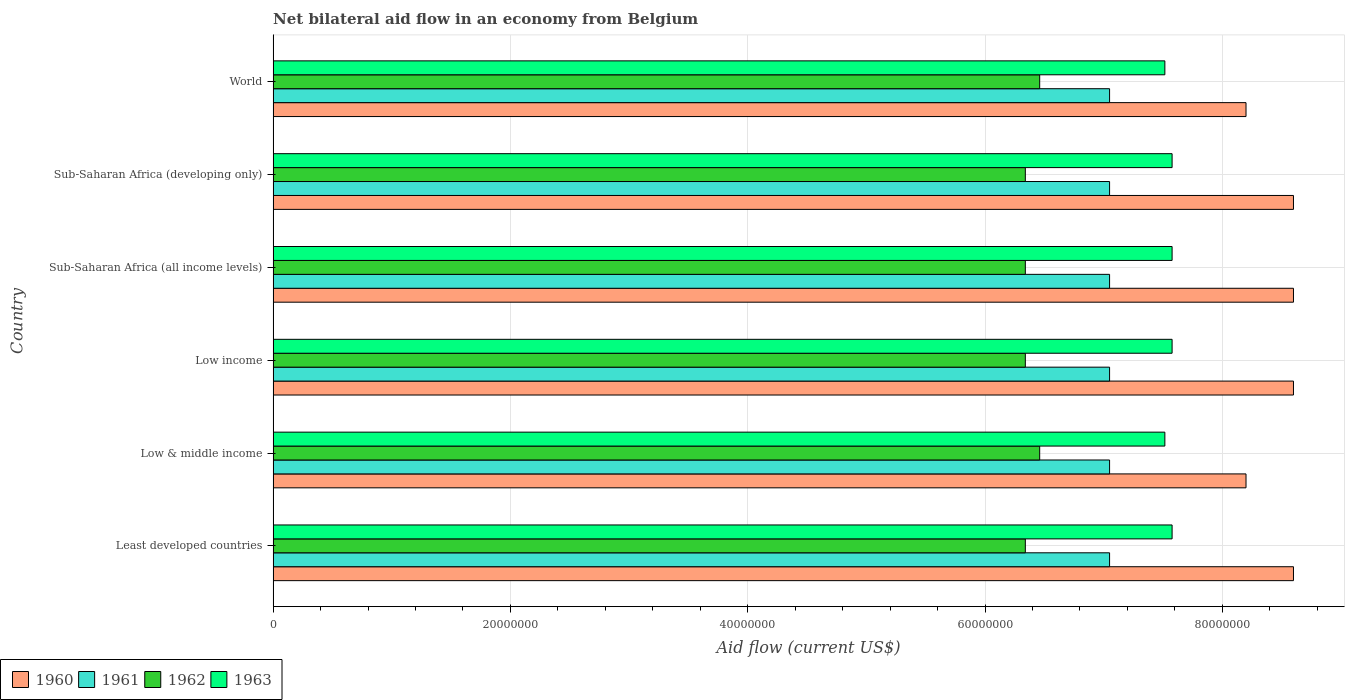Are the number of bars per tick equal to the number of legend labels?
Give a very brief answer. Yes. How many bars are there on the 6th tick from the top?
Your response must be concise. 4. What is the net bilateral aid flow in 1961 in Low & middle income?
Make the answer very short. 7.05e+07. Across all countries, what is the maximum net bilateral aid flow in 1963?
Offer a terse response. 7.58e+07. Across all countries, what is the minimum net bilateral aid flow in 1960?
Keep it short and to the point. 8.20e+07. In which country was the net bilateral aid flow in 1963 maximum?
Make the answer very short. Least developed countries. In which country was the net bilateral aid flow in 1961 minimum?
Make the answer very short. Least developed countries. What is the total net bilateral aid flow in 1963 in the graph?
Your response must be concise. 4.53e+08. What is the difference between the net bilateral aid flow in 1963 in Low income and the net bilateral aid flow in 1962 in Low & middle income?
Offer a terse response. 1.12e+07. What is the average net bilateral aid flow in 1962 per country?
Offer a very short reply. 6.38e+07. What is the difference between the net bilateral aid flow in 1961 and net bilateral aid flow in 1963 in Sub-Saharan Africa (all income levels)?
Your answer should be compact. -5.27e+06. What is the ratio of the net bilateral aid flow in 1962 in Sub-Saharan Africa (all income levels) to that in World?
Your answer should be compact. 0.98. Is the net bilateral aid flow in 1961 in Low & middle income less than that in Sub-Saharan Africa (developing only)?
Keep it short and to the point. No. What is the difference between the highest and the second highest net bilateral aid flow in 1960?
Offer a very short reply. 0. What is the difference between the highest and the lowest net bilateral aid flow in 1962?
Keep it short and to the point. 1.21e+06. In how many countries, is the net bilateral aid flow in 1960 greater than the average net bilateral aid flow in 1960 taken over all countries?
Give a very brief answer. 4. Is the sum of the net bilateral aid flow in 1961 in Low & middle income and World greater than the maximum net bilateral aid flow in 1960 across all countries?
Ensure brevity in your answer.  Yes. Is it the case that in every country, the sum of the net bilateral aid flow in 1961 and net bilateral aid flow in 1962 is greater than the sum of net bilateral aid flow in 1960 and net bilateral aid flow in 1963?
Keep it short and to the point. No. What does the 1st bar from the top in Low income represents?
Provide a short and direct response. 1963. Is it the case that in every country, the sum of the net bilateral aid flow in 1962 and net bilateral aid flow in 1961 is greater than the net bilateral aid flow in 1960?
Your answer should be very brief. Yes. How many bars are there?
Provide a short and direct response. 24. How many countries are there in the graph?
Your response must be concise. 6. Does the graph contain any zero values?
Your answer should be very brief. No. How many legend labels are there?
Offer a terse response. 4. What is the title of the graph?
Offer a very short reply. Net bilateral aid flow in an economy from Belgium. Does "1963" appear as one of the legend labels in the graph?
Provide a short and direct response. Yes. What is the Aid flow (current US$) in 1960 in Least developed countries?
Keep it short and to the point. 8.60e+07. What is the Aid flow (current US$) of 1961 in Least developed countries?
Your answer should be compact. 7.05e+07. What is the Aid flow (current US$) in 1962 in Least developed countries?
Keep it short and to the point. 6.34e+07. What is the Aid flow (current US$) of 1963 in Least developed countries?
Provide a short and direct response. 7.58e+07. What is the Aid flow (current US$) in 1960 in Low & middle income?
Keep it short and to the point. 8.20e+07. What is the Aid flow (current US$) of 1961 in Low & middle income?
Your answer should be very brief. 7.05e+07. What is the Aid flow (current US$) of 1962 in Low & middle income?
Make the answer very short. 6.46e+07. What is the Aid flow (current US$) in 1963 in Low & middle income?
Your answer should be compact. 7.52e+07. What is the Aid flow (current US$) of 1960 in Low income?
Your response must be concise. 8.60e+07. What is the Aid flow (current US$) of 1961 in Low income?
Your response must be concise. 7.05e+07. What is the Aid flow (current US$) in 1962 in Low income?
Provide a short and direct response. 6.34e+07. What is the Aid flow (current US$) in 1963 in Low income?
Offer a very short reply. 7.58e+07. What is the Aid flow (current US$) of 1960 in Sub-Saharan Africa (all income levels)?
Provide a short and direct response. 8.60e+07. What is the Aid flow (current US$) of 1961 in Sub-Saharan Africa (all income levels)?
Offer a terse response. 7.05e+07. What is the Aid flow (current US$) of 1962 in Sub-Saharan Africa (all income levels)?
Your answer should be compact. 6.34e+07. What is the Aid flow (current US$) of 1963 in Sub-Saharan Africa (all income levels)?
Your answer should be very brief. 7.58e+07. What is the Aid flow (current US$) of 1960 in Sub-Saharan Africa (developing only)?
Provide a short and direct response. 8.60e+07. What is the Aid flow (current US$) in 1961 in Sub-Saharan Africa (developing only)?
Offer a terse response. 7.05e+07. What is the Aid flow (current US$) of 1962 in Sub-Saharan Africa (developing only)?
Keep it short and to the point. 6.34e+07. What is the Aid flow (current US$) in 1963 in Sub-Saharan Africa (developing only)?
Your answer should be very brief. 7.58e+07. What is the Aid flow (current US$) in 1960 in World?
Ensure brevity in your answer.  8.20e+07. What is the Aid flow (current US$) in 1961 in World?
Your answer should be very brief. 7.05e+07. What is the Aid flow (current US$) in 1962 in World?
Offer a terse response. 6.46e+07. What is the Aid flow (current US$) of 1963 in World?
Make the answer very short. 7.52e+07. Across all countries, what is the maximum Aid flow (current US$) in 1960?
Give a very brief answer. 8.60e+07. Across all countries, what is the maximum Aid flow (current US$) in 1961?
Provide a succinct answer. 7.05e+07. Across all countries, what is the maximum Aid flow (current US$) of 1962?
Make the answer very short. 6.46e+07. Across all countries, what is the maximum Aid flow (current US$) in 1963?
Offer a terse response. 7.58e+07. Across all countries, what is the minimum Aid flow (current US$) of 1960?
Your answer should be very brief. 8.20e+07. Across all countries, what is the minimum Aid flow (current US$) in 1961?
Offer a very short reply. 7.05e+07. Across all countries, what is the minimum Aid flow (current US$) of 1962?
Your answer should be compact. 6.34e+07. Across all countries, what is the minimum Aid flow (current US$) in 1963?
Make the answer very short. 7.52e+07. What is the total Aid flow (current US$) in 1960 in the graph?
Provide a short and direct response. 5.08e+08. What is the total Aid flow (current US$) in 1961 in the graph?
Your answer should be very brief. 4.23e+08. What is the total Aid flow (current US$) in 1962 in the graph?
Ensure brevity in your answer.  3.83e+08. What is the total Aid flow (current US$) in 1963 in the graph?
Keep it short and to the point. 4.53e+08. What is the difference between the Aid flow (current US$) in 1960 in Least developed countries and that in Low & middle income?
Keep it short and to the point. 4.00e+06. What is the difference between the Aid flow (current US$) in 1962 in Least developed countries and that in Low & middle income?
Your answer should be very brief. -1.21e+06. What is the difference between the Aid flow (current US$) in 1960 in Least developed countries and that in Low income?
Your answer should be compact. 0. What is the difference between the Aid flow (current US$) in 1961 in Least developed countries and that in Low income?
Your response must be concise. 0. What is the difference between the Aid flow (current US$) in 1962 in Least developed countries and that in Low income?
Make the answer very short. 0. What is the difference between the Aid flow (current US$) of 1963 in Least developed countries and that in Low income?
Your response must be concise. 0. What is the difference between the Aid flow (current US$) of 1961 in Least developed countries and that in Sub-Saharan Africa (all income levels)?
Your answer should be compact. 0. What is the difference between the Aid flow (current US$) in 1962 in Least developed countries and that in Sub-Saharan Africa (all income levels)?
Your answer should be compact. 0. What is the difference between the Aid flow (current US$) in 1960 in Least developed countries and that in Sub-Saharan Africa (developing only)?
Give a very brief answer. 0. What is the difference between the Aid flow (current US$) of 1961 in Least developed countries and that in Sub-Saharan Africa (developing only)?
Provide a succinct answer. 0. What is the difference between the Aid flow (current US$) of 1963 in Least developed countries and that in Sub-Saharan Africa (developing only)?
Keep it short and to the point. 0. What is the difference between the Aid flow (current US$) of 1960 in Least developed countries and that in World?
Keep it short and to the point. 4.00e+06. What is the difference between the Aid flow (current US$) in 1962 in Least developed countries and that in World?
Give a very brief answer. -1.21e+06. What is the difference between the Aid flow (current US$) in 1962 in Low & middle income and that in Low income?
Offer a terse response. 1.21e+06. What is the difference between the Aid flow (current US$) of 1963 in Low & middle income and that in Low income?
Your response must be concise. -6.10e+05. What is the difference between the Aid flow (current US$) of 1960 in Low & middle income and that in Sub-Saharan Africa (all income levels)?
Your answer should be very brief. -4.00e+06. What is the difference between the Aid flow (current US$) of 1961 in Low & middle income and that in Sub-Saharan Africa (all income levels)?
Offer a terse response. 0. What is the difference between the Aid flow (current US$) in 1962 in Low & middle income and that in Sub-Saharan Africa (all income levels)?
Offer a very short reply. 1.21e+06. What is the difference between the Aid flow (current US$) of 1963 in Low & middle income and that in Sub-Saharan Africa (all income levels)?
Keep it short and to the point. -6.10e+05. What is the difference between the Aid flow (current US$) in 1960 in Low & middle income and that in Sub-Saharan Africa (developing only)?
Ensure brevity in your answer.  -4.00e+06. What is the difference between the Aid flow (current US$) in 1961 in Low & middle income and that in Sub-Saharan Africa (developing only)?
Your answer should be very brief. 0. What is the difference between the Aid flow (current US$) of 1962 in Low & middle income and that in Sub-Saharan Africa (developing only)?
Ensure brevity in your answer.  1.21e+06. What is the difference between the Aid flow (current US$) in 1963 in Low & middle income and that in Sub-Saharan Africa (developing only)?
Your answer should be compact. -6.10e+05. What is the difference between the Aid flow (current US$) in 1960 in Low & middle income and that in World?
Your answer should be very brief. 0. What is the difference between the Aid flow (current US$) of 1961 in Low & middle income and that in World?
Keep it short and to the point. 0. What is the difference between the Aid flow (current US$) in 1962 in Low & middle income and that in World?
Ensure brevity in your answer.  0. What is the difference between the Aid flow (current US$) in 1961 in Low income and that in Sub-Saharan Africa (all income levels)?
Keep it short and to the point. 0. What is the difference between the Aid flow (current US$) in 1962 in Low income and that in Sub-Saharan Africa (developing only)?
Offer a terse response. 0. What is the difference between the Aid flow (current US$) of 1960 in Low income and that in World?
Your response must be concise. 4.00e+06. What is the difference between the Aid flow (current US$) of 1962 in Low income and that in World?
Give a very brief answer. -1.21e+06. What is the difference between the Aid flow (current US$) in 1961 in Sub-Saharan Africa (all income levels) and that in Sub-Saharan Africa (developing only)?
Give a very brief answer. 0. What is the difference between the Aid flow (current US$) in 1963 in Sub-Saharan Africa (all income levels) and that in Sub-Saharan Africa (developing only)?
Give a very brief answer. 0. What is the difference between the Aid flow (current US$) of 1962 in Sub-Saharan Africa (all income levels) and that in World?
Your answer should be very brief. -1.21e+06. What is the difference between the Aid flow (current US$) of 1963 in Sub-Saharan Africa (all income levels) and that in World?
Keep it short and to the point. 6.10e+05. What is the difference between the Aid flow (current US$) of 1960 in Sub-Saharan Africa (developing only) and that in World?
Keep it short and to the point. 4.00e+06. What is the difference between the Aid flow (current US$) in 1962 in Sub-Saharan Africa (developing only) and that in World?
Give a very brief answer. -1.21e+06. What is the difference between the Aid flow (current US$) in 1963 in Sub-Saharan Africa (developing only) and that in World?
Make the answer very short. 6.10e+05. What is the difference between the Aid flow (current US$) of 1960 in Least developed countries and the Aid flow (current US$) of 1961 in Low & middle income?
Your answer should be compact. 1.55e+07. What is the difference between the Aid flow (current US$) in 1960 in Least developed countries and the Aid flow (current US$) in 1962 in Low & middle income?
Give a very brief answer. 2.14e+07. What is the difference between the Aid flow (current US$) of 1960 in Least developed countries and the Aid flow (current US$) of 1963 in Low & middle income?
Ensure brevity in your answer.  1.08e+07. What is the difference between the Aid flow (current US$) of 1961 in Least developed countries and the Aid flow (current US$) of 1962 in Low & middle income?
Ensure brevity in your answer.  5.89e+06. What is the difference between the Aid flow (current US$) of 1961 in Least developed countries and the Aid flow (current US$) of 1963 in Low & middle income?
Your answer should be very brief. -4.66e+06. What is the difference between the Aid flow (current US$) of 1962 in Least developed countries and the Aid flow (current US$) of 1963 in Low & middle income?
Provide a short and direct response. -1.18e+07. What is the difference between the Aid flow (current US$) in 1960 in Least developed countries and the Aid flow (current US$) in 1961 in Low income?
Offer a very short reply. 1.55e+07. What is the difference between the Aid flow (current US$) of 1960 in Least developed countries and the Aid flow (current US$) of 1962 in Low income?
Keep it short and to the point. 2.26e+07. What is the difference between the Aid flow (current US$) of 1960 in Least developed countries and the Aid flow (current US$) of 1963 in Low income?
Your answer should be compact. 1.02e+07. What is the difference between the Aid flow (current US$) of 1961 in Least developed countries and the Aid flow (current US$) of 1962 in Low income?
Provide a succinct answer. 7.10e+06. What is the difference between the Aid flow (current US$) in 1961 in Least developed countries and the Aid flow (current US$) in 1963 in Low income?
Your answer should be compact. -5.27e+06. What is the difference between the Aid flow (current US$) in 1962 in Least developed countries and the Aid flow (current US$) in 1963 in Low income?
Provide a succinct answer. -1.24e+07. What is the difference between the Aid flow (current US$) of 1960 in Least developed countries and the Aid flow (current US$) of 1961 in Sub-Saharan Africa (all income levels)?
Your answer should be very brief. 1.55e+07. What is the difference between the Aid flow (current US$) in 1960 in Least developed countries and the Aid flow (current US$) in 1962 in Sub-Saharan Africa (all income levels)?
Your answer should be very brief. 2.26e+07. What is the difference between the Aid flow (current US$) of 1960 in Least developed countries and the Aid flow (current US$) of 1963 in Sub-Saharan Africa (all income levels)?
Provide a succinct answer. 1.02e+07. What is the difference between the Aid flow (current US$) of 1961 in Least developed countries and the Aid flow (current US$) of 1962 in Sub-Saharan Africa (all income levels)?
Your answer should be very brief. 7.10e+06. What is the difference between the Aid flow (current US$) of 1961 in Least developed countries and the Aid flow (current US$) of 1963 in Sub-Saharan Africa (all income levels)?
Your answer should be compact. -5.27e+06. What is the difference between the Aid flow (current US$) of 1962 in Least developed countries and the Aid flow (current US$) of 1963 in Sub-Saharan Africa (all income levels)?
Give a very brief answer. -1.24e+07. What is the difference between the Aid flow (current US$) in 1960 in Least developed countries and the Aid flow (current US$) in 1961 in Sub-Saharan Africa (developing only)?
Offer a very short reply. 1.55e+07. What is the difference between the Aid flow (current US$) in 1960 in Least developed countries and the Aid flow (current US$) in 1962 in Sub-Saharan Africa (developing only)?
Offer a very short reply. 2.26e+07. What is the difference between the Aid flow (current US$) of 1960 in Least developed countries and the Aid flow (current US$) of 1963 in Sub-Saharan Africa (developing only)?
Make the answer very short. 1.02e+07. What is the difference between the Aid flow (current US$) of 1961 in Least developed countries and the Aid flow (current US$) of 1962 in Sub-Saharan Africa (developing only)?
Provide a succinct answer. 7.10e+06. What is the difference between the Aid flow (current US$) of 1961 in Least developed countries and the Aid flow (current US$) of 1963 in Sub-Saharan Africa (developing only)?
Make the answer very short. -5.27e+06. What is the difference between the Aid flow (current US$) in 1962 in Least developed countries and the Aid flow (current US$) in 1963 in Sub-Saharan Africa (developing only)?
Ensure brevity in your answer.  -1.24e+07. What is the difference between the Aid flow (current US$) of 1960 in Least developed countries and the Aid flow (current US$) of 1961 in World?
Your answer should be very brief. 1.55e+07. What is the difference between the Aid flow (current US$) of 1960 in Least developed countries and the Aid flow (current US$) of 1962 in World?
Offer a very short reply. 2.14e+07. What is the difference between the Aid flow (current US$) in 1960 in Least developed countries and the Aid flow (current US$) in 1963 in World?
Offer a very short reply. 1.08e+07. What is the difference between the Aid flow (current US$) in 1961 in Least developed countries and the Aid flow (current US$) in 1962 in World?
Give a very brief answer. 5.89e+06. What is the difference between the Aid flow (current US$) of 1961 in Least developed countries and the Aid flow (current US$) of 1963 in World?
Keep it short and to the point. -4.66e+06. What is the difference between the Aid flow (current US$) in 1962 in Least developed countries and the Aid flow (current US$) in 1963 in World?
Provide a short and direct response. -1.18e+07. What is the difference between the Aid flow (current US$) in 1960 in Low & middle income and the Aid flow (current US$) in 1961 in Low income?
Offer a very short reply. 1.15e+07. What is the difference between the Aid flow (current US$) in 1960 in Low & middle income and the Aid flow (current US$) in 1962 in Low income?
Provide a succinct answer. 1.86e+07. What is the difference between the Aid flow (current US$) of 1960 in Low & middle income and the Aid flow (current US$) of 1963 in Low income?
Offer a very short reply. 6.23e+06. What is the difference between the Aid flow (current US$) in 1961 in Low & middle income and the Aid flow (current US$) in 1962 in Low income?
Make the answer very short. 7.10e+06. What is the difference between the Aid flow (current US$) in 1961 in Low & middle income and the Aid flow (current US$) in 1963 in Low income?
Your response must be concise. -5.27e+06. What is the difference between the Aid flow (current US$) in 1962 in Low & middle income and the Aid flow (current US$) in 1963 in Low income?
Give a very brief answer. -1.12e+07. What is the difference between the Aid flow (current US$) in 1960 in Low & middle income and the Aid flow (current US$) in 1961 in Sub-Saharan Africa (all income levels)?
Make the answer very short. 1.15e+07. What is the difference between the Aid flow (current US$) of 1960 in Low & middle income and the Aid flow (current US$) of 1962 in Sub-Saharan Africa (all income levels)?
Offer a terse response. 1.86e+07. What is the difference between the Aid flow (current US$) in 1960 in Low & middle income and the Aid flow (current US$) in 1963 in Sub-Saharan Africa (all income levels)?
Your answer should be very brief. 6.23e+06. What is the difference between the Aid flow (current US$) in 1961 in Low & middle income and the Aid flow (current US$) in 1962 in Sub-Saharan Africa (all income levels)?
Provide a short and direct response. 7.10e+06. What is the difference between the Aid flow (current US$) of 1961 in Low & middle income and the Aid flow (current US$) of 1963 in Sub-Saharan Africa (all income levels)?
Provide a succinct answer. -5.27e+06. What is the difference between the Aid flow (current US$) of 1962 in Low & middle income and the Aid flow (current US$) of 1963 in Sub-Saharan Africa (all income levels)?
Your answer should be compact. -1.12e+07. What is the difference between the Aid flow (current US$) of 1960 in Low & middle income and the Aid flow (current US$) of 1961 in Sub-Saharan Africa (developing only)?
Your answer should be compact. 1.15e+07. What is the difference between the Aid flow (current US$) in 1960 in Low & middle income and the Aid flow (current US$) in 1962 in Sub-Saharan Africa (developing only)?
Ensure brevity in your answer.  1.86e+07. What is the difference between the Aid flow (current US$) in 1960 in Low & middle income and the Aid flow (current US$) in 1963 in Sub-Saharan Africa (developing only)?
Your answer should be very brief. 6.23e+06. What is the difference between the Aid flow (current US$) in 1961 in Low & middle income and the Aid flow (current US$) in 1962 in Sub-Saharan Africa (developing only)?
Your answer should be very brief. 7.10e+06. What is the difference between the Aid flow (current US$) of 1961 in Low & middle income and the Aid flow (current US$) of 1963 in Sub-Saharan Africa (developing only)?
Offer a terse response. -5.27e+06. What is the difference between the Aid flow (current US$) of 1962 in Low & middle income and the Aid flow (current US$) of 1963 in Sub-Saharan Africa (developing only)?
Provide a succinct answer. -1.12e+07. What is the difference between the Aid flow (current US$) in 1960 in Low & middle income and the Aid flow (current US$) in 1961 in World?
Keep it short and to the point. 1.15e+07. What is the difference between the Aid flow (current US$) of 1960 in Low & middle income and the Aid flow (current US$) of 1962 in World?
Keep it short and to the point. 1.74e+07. What is the difference between the Aid flow (current US$) in 1960 in Low & middle income and the Aid flow (current US$) in 1963 in World?
Make the answer very short. 6.84e+06. What is the difference between the Aid flow (current US$) in 1961 in Low & middle income and the Aid flow (current US$) in 1962 in World?
Offer a very short reply. 5.89e+06. What is the difference between the Aid flow (current US$) in 1961 in Low & middle income and the Aid flow (current US$) in 1963 in World?
Provide a succinct answer. -4.66e+06. What is the difference between the Aid flow (current US$) of 1962 in Low & middle income and the Aid flow (current US$) of 1963 in World?
Give a very brief answer. -1.06e+07. What is the difference between the Aid flow (current US$) of 1960 in Low income and the Aid flow (current US$) of 1961 in Sub-Saharan Africa (all income levels)?
Provide a short and direct response. 1.55e+07. What is the difference between the Aid flow (current US$) in 1960 in Low income and the Aid flow (current US$) in 1962 in Sub-Saharan Africa (all income levels)?
Provide a succinct answer. 2.26e+07. What is the difference between the Aid flow (current US$) in 1960 in Low income and the Aid flow (current US$) in 1963 in Sub-Saharan Africa (all income levels)?
Your answer should be very brief. 1.02e+07. What is the difference between the Aid flow (current US$) of 1961 in Low income and the Aid flow (current US$) of 1962 in Sub-Saharan Africa (all income levels)?
Ensure brevity in your answer.  7.10e+06. What is the difference between the Aid flow (current US$) of 1961 in Low income and the Aid flow (current US$) of 1963 in Sub-Saharan Africa (all income levels)?
Give a very brief answer. -5.27e+06. What is the difference between the Aid flow (current US$) in 1962 in Low income and the Aid flow (current US$) in 1963 in Sub-Saharan Africa (all income levels)?
Provide a succinct answer. -1.24e+07. What is the difference between the Aid flow (current US$) of 1960 in Low income and the Aid flow (current US$) of 1961 in Sub-Saharan Africa (developing only)?
Provide a succinct answer. 1.55e+07. What is the difference between the Aid flow (current US$) of 1960 in Low income and the Aid flow (current US$) of 1962 in Sub-Saharan Africa (developing only)?
Ensure brevity in your answer.  2.26e+07. What is the difference between the Aid flow (current US$) of 1960 in Low income and the Aid flow (current US$) of 1963 in Sub-Saharan Africa (developing only)?
Provide a succinct answer. 1.02e+07. What is the difference between the Aid flow (current US$) of 1961 in Low income and the Aid flow (current US$) of 1962 in Sub-Saharan Africa (developing only)?
Ensure brevity in your answer.  7.10e+06. What is the difference between the Aid flow (current US$) in 1961 in Low income and the Aid flow (current US$) in 1963 in Sub-Saharan Africa (developing only)?
Offer a very short reply. -5.27e+06. What is the difference between the Aid flow (current US$) of 1962 in Low income and the Aid flow (current US$) of 1963 in Sub-Saharan Africa (developing only)?
Offer a very short reply. -1.24e+07. What is the difference between the Aid flow (current US$) of 1960 in Low income and the Aid flow (current US$) of 1961 in World?
Offer a very short reply. 1.55e+07. What is the difference between the Aid flow (current US$) in 1960 in Low income and the Aid flow (current US$) in 1962 in World?
Your response must be concise. 2.14e+07. What is the difference between the Aid flow (current US$) in 1960 in Low income and the Aid flow (current US$) in 1963 in World?
Offer a very short reply. 1.08e+07. What is the difference between the Aid flow (current US$) in 1961 in Low income and the Aid flow (current US$) in 1962 in World?
Make the answer very short. 5.89e+06. What is the difference between the Aid flow (current US$) of 1961 in Low income and the Aid flow (current US$) of 1963 in World?
Keep it short and to the point. -4.66e+06. What is the difference between the Aid flow (current US$) of 1962 in Low income and the Aid flow (current US$) of 1963 in World?
Your answer should be compact. -1.18e+07. What is the difference between the Aid flow (current US$) of 1960 in Sub-Saharan Africa (all income levels) and the Aid flow (current US$) of 1961 in Sub-Saharan Africa (developing only)?
Keep it short and to the point. 1.55e+07. What is the difference between the Aid flow (current US$) in 1960 in Sub-Saharan Africa (all income levels) and the Aid flow (current US$) in 1962 in Sub-Saharan Africa (developing only)?
Offer a terse response. 2.26e+07. What is the difference between the Aid flow (current US$) of 1960 in Sub-Saharan Africa (all income levels) and the Aid flow (current US$) of 1963 in Sub-Saharan Africa (developing only)?
Provide a succinct answer. 1.02e+07. What is the difference between the Aid flow (current US$) of 1961 in Sub-Saharan Africa (all income levels) and the Aid flow (current US$) of 1962 in Sub-Saharan Africa (developing only)?
Your answer should be very brief. 7.10e+06. What is the difference between the Aid flow (current US$) of 1961 in Sub-Saharan Africa (all income levels) and the Aid flow (current US$) of 1963 in Sub-Saharan Africa (developing only)?
Keep it short and to the point. -5.27e+06. What is the difference between the Aid flow (current US$) of 1962 in Sub-Saharan Africa (all income levels) and the Aid flow (current US$) of 1963 in Sub-Saharan Africa (developing only)?
Provide a short and direct response. -1.24e+07. What is the difference between the Aid flow (current US$) in 1960 in Sub-Saharan Africa (all income levels) and the Aid flow (current US$) in 1961 in World?
Make the answer very short. 1.55e+07. What is the difference between the Aid flow (current US$) in 1960 in Sub-Saharan Africa (all income levels) and the Aid flow (current US$) in 1962 in World?
Provide a short and direct response. 2.14e+07. What is the difference between the Aid flow (current US$) in 1960 in Sub-Saharan Africa (all income levels) and the Aid flow (current US$) in 1963 in World?
Your answer should be very brief. 1.08e+07. What is the difference between the Aid flow (current US$) of 1961 in Sub-Saharan Africa (all income levels) and the Aid flow (current US$) of 1962 in World?
Offer a terse response. 5.89e+06. What is the difference between the Aid flow (current US$) of 1961 in Sub-Saharan Africa (all income levels) and the Aid flow (current US$) of 1963 in World?
Provide a succinct answer. -4.66e+06. What is the difference between the Aid flow (current US$) of 1962 in Sub-Saharan Africa (all income levels) and the Aid flow (current US$) of 1963 in World?
Give a very brief answer. -1.18e+07. What is the difference between the Aid flow (current US$) of 1960 in Sub-Saharan Africa (developing only) and the Aid flow (current US$) of 1961 in World?
Offer a terse response. 1.55e+07. What is the difference between the Aid flow (current US$) in 1960 in Sub-Saharan Africa (developing only) and the Aid flow (current US$) in 1962 in World?
Give a very brief answer. 2.14e+07. What is the difference between the Aid flow (current US$) in 1960 in Sub-Saharan Africa (developing only) and the Aid flow (current US$) in 1963 in World?
Ensure brevity in your answer.  1.08e+07. What is the difference between the Aid flow (current US$) in 1961 in Sub-Saharan Africa (developing only) and the Aid flow (current US$) in 1962 in World?
Your response must be concise. 5.89e+06. What is the difference between the Aid flow (current US$) of 1961 in Sub-Saharan Africa (developing only) and the Aid flow (current US$) of 1963 in World?
Make the answer very short. -4.66e+06. What is the difference between the Aid flow (current US$) of 1962 in Sub-Saharan Africa (developing only) and the Aid flow (current US$) of 1963 in World?
Offer a terse response. -1.18e+07. What is the average Aid flow (current US$) in 1960 per country?
Keep it short and to the point. 8.47e+07. What is the average Aid flow (current US$) in 1961 per country?
Provide a short and direct response. 7.05e+07. What is the average Aid flow (current US$) in 1962 per country?
Offer a very short reply. 6.38e+07. What is the average Aid flow (current US$) of 1963 per country?
Offer a terse response. 7.56e+07. What is the difference between the Aid flow (current US$) of 1960 and Aid flow (current US$) of 1961 in Least developed countries?
Your answer should be very brief. 1.55e+07. What is the difference between the Aid flow (current US$) in 1960 and Aid flow (current US$) in 1962 in Least developed countries?
Give a very brief answer. 2.26e+07. What is the difference between the Aid flow (current US$) in 1960 and Aid flow (current US$) in 1963 in Least developed countries?
Keep it short and to the point. 1.02e+07. What is the difference between the Aid flow (current US$) in 1961 and Aid flow (current US$) in 1962 in Least developed countries?
Offer a terse response. 7.10e+06. What is the difference between the Aid flow (current US$) of 1961 and Aid flow (current US$) of 1963 in Least developed countries?
Your answer should be compact. -5.27e+06. What is the difference between the Aid flow (current US$) of 1962 and Aid flow (current US$) of 1963 in Least developed countries?
Offer a very short reply. -1.24e+07. What is the difference between the Aid flow (current US$) of 1960 and Aid flow (current US$) of 1961 in Low & middle income?
Your response must be concise. 1.15e+07. What is the difference between the Aid flow (current US$) in 1960 and Aid flow (current US$) in 1962 in Low & middle income?
Offer a terse response. 1.74e+07. What is the difference between the Aid flow (current US$) of 1960 and Aid flow (current US$) of 1963 in Low & middle income?
Offer a very short reply. 6.84e+06. What is the difference between the Aid flow (current US$) in 1961 and Aid flow (current US$) in 1962 in Low & middle income?
Make the answer very short. 5.89e+06. What is the difference between the Aid flow (current US$) of 1961 and Aid flow (current US$) of 1963 in Low & middle income?
Ensure brevity in your answer.  -4.66e+06. What is the difference between the Aid flow (current US$) in 1962 and Aid flow (current US$) in 1963 in Low & middle income?
Keep it short and to the point. -1.06e+07. What is the difference between the Aid flow (current US$) of 1960 and Aid flow (current US$) of 1961 in Low income?
Provide a short and direct response. 1.55e+07. What is the difference between the Aid flow (current US$) of 1960 and Aid flow (current US$) of 1962 in Low income?
Offer a terse response. 2.26e+07. What is the difference between the Aid flow (current US$) in 1960 and Aid flow (current US$) in 1963 in Low income?
Give a very brief answer. 1.02e+07. What is the difference between the Aid flow (current US$) in 1961 and Aid flow (current US$) in 1962 in Low income?
Make the answer very short. 7.10e+06. What is the difference between the Aid flow (current US$) in 1961 and Aid flow (current US$) in 1963 in Low income?
Ensure brevity in your answer.  -5.27e+06. What is the difference between the Aid flow (current US$) in 1962 and Aid flow (current US$) in 1963 in Low income?
Your answer should be compact. -1.24e+07. What is the difference between the Aid flow (current US$) of 1960 and Aid flow (current US$) of 1961 in Sub-Saharan Africa (all income levels)?
Keep it short and to the point. 1.55e+07. What is the difference between the Aid flow (current US$) of 1960 and Aid flow (current US$) of 1962 in Sub-Saharan Africa (all income levels)?
Provide a succinct answer. 2.26e+07. What is the difference between the Aid flow (current US$) in 1960 and Aid flow (current US$) in 1963 in Sub-Saharan Africa (all income levels)?
Your answer should be very brief. 1.02e+07. What is the difference between the Aid flow (current US$) of 1961 and Aid flow (current US$) of 1962 in Sub-Saharan Africa (all income levels)?
Your answer should be compact. 7.10e+06. What is the difference between the Aid flow (current US$) in 1961 and Aid flow (current US$) in 1963 in Sub-Saharan Africa (all income levels)?
Give a very brief answer. -5.27e+06. What is the difference between the Aid flow (current US$) of 1962 and Aid flow (current US$) of 1963 in Sub-Saharan Africa (all income levels)?
Provide a succinct answer. -1.24e+07. What is the difference between the Aid flow (current US$) in 1960 and Aid flow (current US$) in 1961 in Sub-Saharan Africa (developing only)?
Offer a terse response. 1.55e+07. What is the difference between the Aid flow (current US$) in 1960 and Aid flow (current US$) in 1962 in Sub-Saharan Africa (developing only)?
Offer a terse response. 2.26e+07. What is the difference between the Aid flow (current US$) of 1960 and Aid flow (current US$) of 1963 in Sub-Saharan Africa (developing only)?
Your answer should be compact. 1.02e+07. What is the difference between the Aid flow (current US$) in 1961 and Aid flow (current US$) in 1962 in Sub-Saharan Africa (developing only)?
Your answer should be very brief. 7.10e+06. What is the difference between the Aid flow (current US$) in 1961 and Aid flow (current US$) in 1963 in Sub-Saharan Africa (developing only)?
Make the answer very short. -5.27e+06. What is the difference between the Aid flow (current US$) of 1962 and Aid flow (current US$) of 1963 in Sub-Saharan Africa (developing only)?
Your response must be concise. -1.24e+07. What is the difference between the Aid flow (current US$) of 1960 and Aid flow (current US$) of 1961 in World?
Your answer should be compact. 1.15e+07. What is the difference between the Aid flow (current US$) of 1960 and Aid flow (current US$) of 1962 in World?
Keep it short and to the point. 1.74e+07. What is the difference between the Aid flow (current US$) in 1960 and Aid flow (current US$) in 1963 in World?
Offer a very short reply. 6.84e+06. What is the difference between the Aid flow (current US$) in 1961 and Aid flow (current US$) in 1962 in World?
Offer a very short reply. 5.89e+06. What is the difference between the Aid flow (current US$) of 1961 and Aid flow (current US$) of 1963 in World?
Your response must be concise. -4.66e+06. What is the difference between the Aid flow (current US$) in 1962 and Aid flow (current US$) in 1963 in World?
Your response must be concise. -1.06e+07. What is the ratio of the Aid flow (current US$) in 1960 in Least developed countries to that in Low & middle income?
Your answer should be compact. 1.05. What is the ratio of the Aid flow (current US$) of 1961 in Least developed countries to that in Low & middle income?
Ensure brevity in your answer.  1. What is the ratio of the Aid flow (current US$) of 1962 in Least developed countries to that in Low & middle income?
Offer a terse response. 0.98. What is the ratio of the Aid flow (current US$) in 1960 in Least developed countries to that in Low income?
Your answer should be compact. 1. What is the ratio of the Aid flow (current US$) in 1961 in Least developed countries to that in Low income?
Make the answer very short. 1. What is the ratio of the Aid flow (current US$) of 1960 in Least developed countries to that in Sub-Saharan Africa (all income levels)?
Give a very brief answer. 1. What is the ratio of the Aid flow (current US$) of 1963 in Least developed countries to that in Sub-Saharan Africa (all income levels)?
Provide a succinct answer. 1. What is the ratio of the Aid flow (current US$) in 1960 in Least developed countries to that in World?
Make the answer very short. 1.05. What is the ratio of the Aid flow (current US$) in 1962 in Least developed countries to that in World?
Keep it short and to the point. 0.98. What is the ratio of the Aid flow (current US$) in 1963 in Least developed countries to that in World?
Keep it short and to the point. 1.01. What is the ratio of the Aid flow (current US$) in 1960 in Low & middle income to that in Low income?
Ensure brevity in your answer.  0.95. What is the ratio of the Aid flow (current US$) in 1962 in Low & middle income to that in Low income?
Offer a terse response. 1.02. What is the ratio of the Aid flow (current US$) in 1960 in Low & middle income to that in Sub-Saharan Africa (all income levels)?
Your response must be concise. 0.95. What is the ratio of the Aid flow (current US$) in 1961 in Low & middle income to that in Sub-Saharan Africa (all income levels)?
Provide a short and direct response. 1. What is the ratio of the Aid flow (current US$) of 1962 in Low & middle income to that in Sub-Saharan Africa (all income levels)?
Keep it short and to the point. 1.02. What is the ratio of the Aid flow (current US$) in 1960 in Low & middle income to that in Sub-Saharan Africa (developing only)?
Your response must be concise. 0.95. What is the ratio of the Aid flow (current US$) of 1961 in Low & middle income to that in Sub-Saharan Africa (developing only)?
Your answer should be very brief. 1. What is the ratio of the Aid flow (current US$) in 1962 in Low & middle income to that in Sub-Saharan Africa (developing only)?
Offer a very short reply. 1.02. What is the ratio of the Aid flow (current US$) of 1963 in Low & middle income to that in Sub-Saharan Africa (developing only)?
Your response must be concise. 0.99. What is the ratio of the Aid flow (current US$) of 1962 in Low & middle income to that in World?
Your answer should be compact. 1. What is the ratio of the Aid flow (current US$) in 1960 in Low income to that in Sub-Saharan Africa (all income levels)?
Your answer should be compact. 1. What is the ratio of the Aid flow (current US$) of 1962 in Low income to that in Sub-Saharan Africa (all income levels)?
Your answer should be compact. 1. What is the ratio of the Aid flow (current US$) of 1961 in Low income to that in Sub-Saharan Africa (developing only)?
Provide a short and direct response. 1. What is the ratio of the Aid flow (current US$) in 1962 in Low income to that in Sub-Saharan Africa (developing only)?
Offer a very short reply. 1. What is the ratio of the Aid flow (current US$) of 1960 in Low income to that in World?
Your answer should be very brief. 1.05. What is the ratio of the Aid flow (current US$) in 1962 in Low income to that in World?
Offer a very short reply. 0.98. What is the ratio of the Aid flow (current US$) in 1963 in Low income to that in World?
Provide a succinct answer. 1.01. What is the ratio of the Aid flow (current US$) in 1960 in Sub-Saharan Africa (all income levels) to that in World?
Ensure brevity in your answer.  1.05. What is the ratio of the Aid flow (current US$) in 1961 in Sub-Saharan Africa (all income levels) to that in World?
Keep it short and to the point. 1. What is the ratio of the Aid flow (current US$) of 1962 in Sub-Saharan Africa (all income levels) to that in World?
Make the answer very short. 0.98. What is the ratio of the Aid flow (current US$) in 1963 in Sub-Saharan Africa (all income levels) to that in World?
Offer a terse response. 1.01. What is the ratio of the Aid flow (current US$) of 1960 in Sub-Saharan Africa (developing only) to that in World?
Make the answer very short. 1.05. What is the ratio of the Aid flow (current US$) of 1961 in Sub-Saharan Africa (developing only) to that in World?
Give a very brief answer. 1. What is the ratio of the Aid flow (current US$) in 1962 in Sub-Saharan Africa (developing only) to that in World?
Your response must be concise. 0.98. What is the ratio of the Aid flow (current US$) in 1963 in Sub-Saharan Africa (developing only) to that in World?
Provide a succinct answer. 1.01. What is the difference between the highest and the second highest Aid flow (current US$) of 1963?
Your response must be concise. 0. What is the difference between the highest and the lowest Aid flow (current US$) of 1962?
Keep it short and to the point. 1.21e+06. 